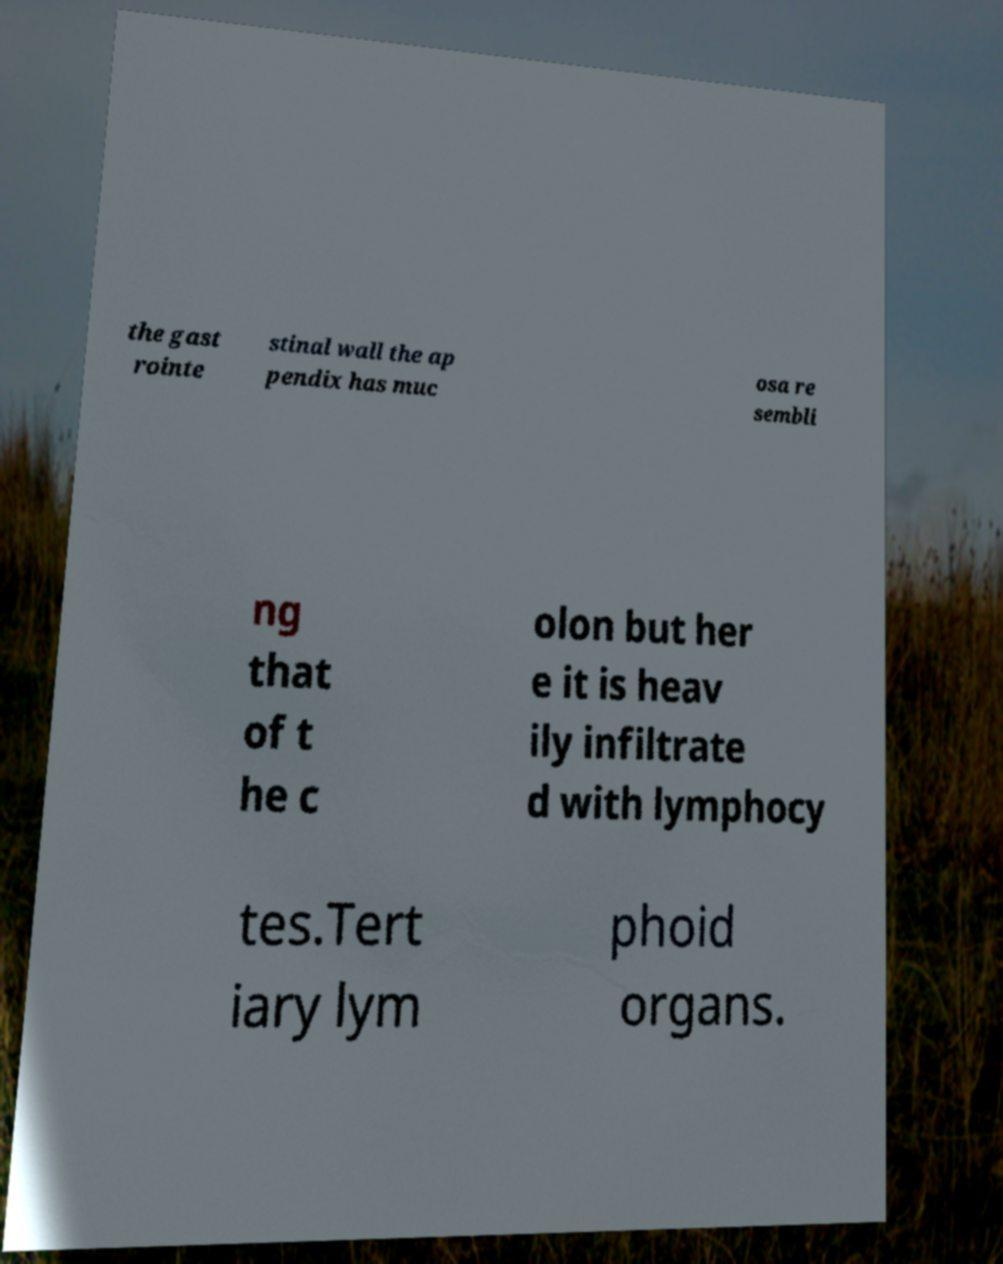Could you assist in decoding the text presented in this image and type it out clearly? the gast rointe stinal wall the ap pendix has muc osa re sembli ng that of t he c olon but her e it is heav ily infiltrate d with lymphocy tes.Tert iary lym phoid organs. 